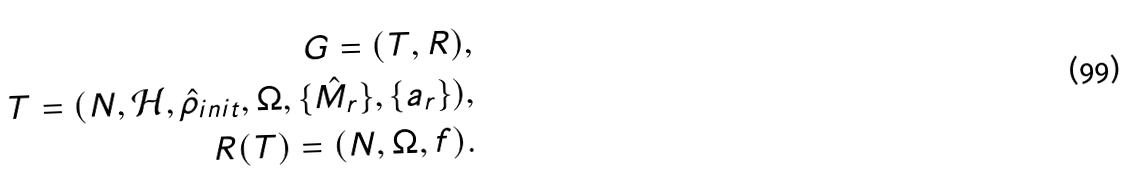Convert formula to latex. <formula><loc_0><loc_0><loc_500><loc_500>G = ( T , R ) , \\ T = ( N , \mathcal { H } , \hat { \rho } _ { i n i t } , \Omega , \{ \hat { M } _ { r } \} , \{ a _ { r } \} ) , \\ R ( T ) = ( N , \Omega , f ) .</formula> 